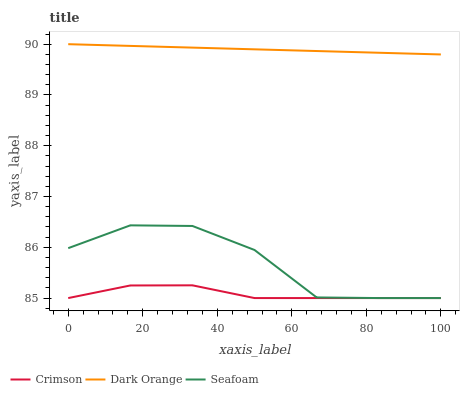Does Crimson have the minimum area under the curve?
Answer yes or no. Yes. Does Dark Orange have the maximum area under the curve?
Answer yes or no. Yes. Does Seafoam have the minimum area under the curve?
Answer yes or no. No. Does Seafoam have the maximum area under the curve?
Answer yes or no. No. Is Dark Orange the smoothest?
Answer yes or no. Yes. Is Seafoam the roughest?
Answer yes or no. Yes. Is Seafoam the smoothest?
Answer yes or no. No. Is Dark Orange the roughest?
Answer yes or no. No. Does Crimson have the lowest value?
Answer yes or no. Yes. Does Dark Orange have the lowest value?
Answer yes or no. No. Does Dark Orange have the highest value?
Answer yes or no. Yes. Does Seafoam have the highest value?
Answer yes or no. No. Is Crimson less than Dark Orange?
Answer yes or no. Yes. Is Dark Orange greater than Seafoam?
Answer yes or no. Yes. Does Seafoam intersect Crimson?
Answer yes or no. Yes. Is Seafoam less than Crimson?
Answer yes or no. No. Is Seafoam greater than Crimson?
Answer yes or no. No. Does Crimson intersect Dark Orange?
Answer yes or no. No. 